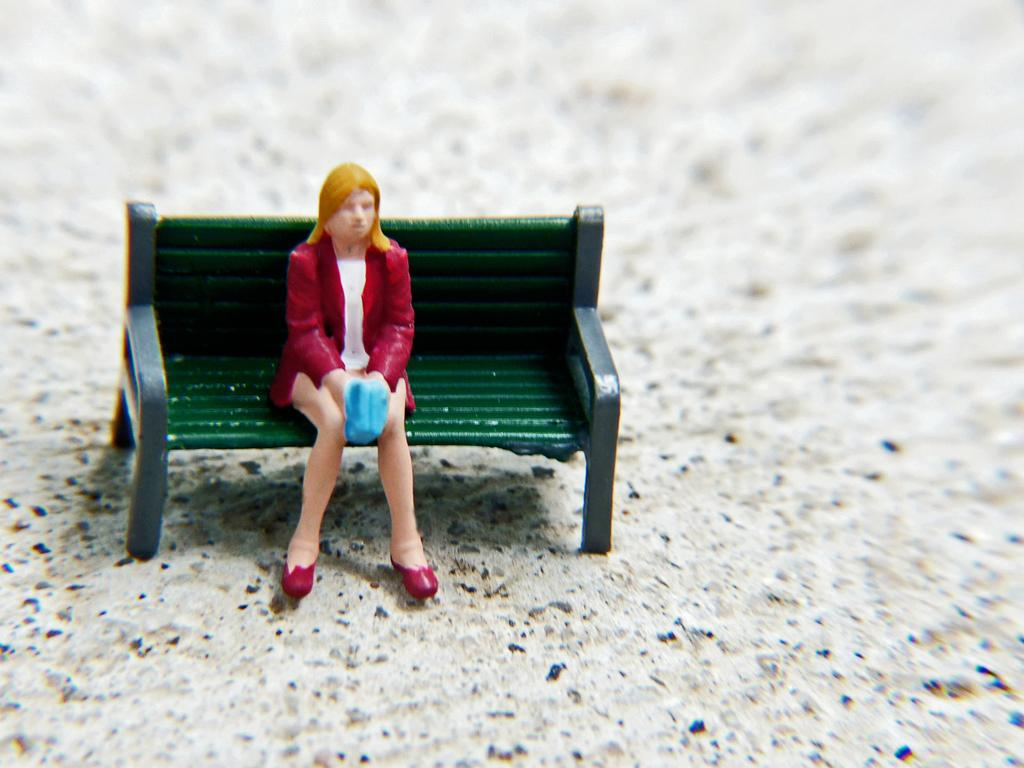Where was the image taken? The image is taken indoors. What can be seen at the bottom of the image? There is a floor visible at the bottom of the image. What is the main object in the middle of the image? There is a toy couch in the middle of the image. What is the toy girl doing on the couch? A toy girl is sitting on the couch. What color are the eyes of the toy girl in the image? There are no visible eyes on the toy girl in the image, as it is a toy and does not have facial features. 